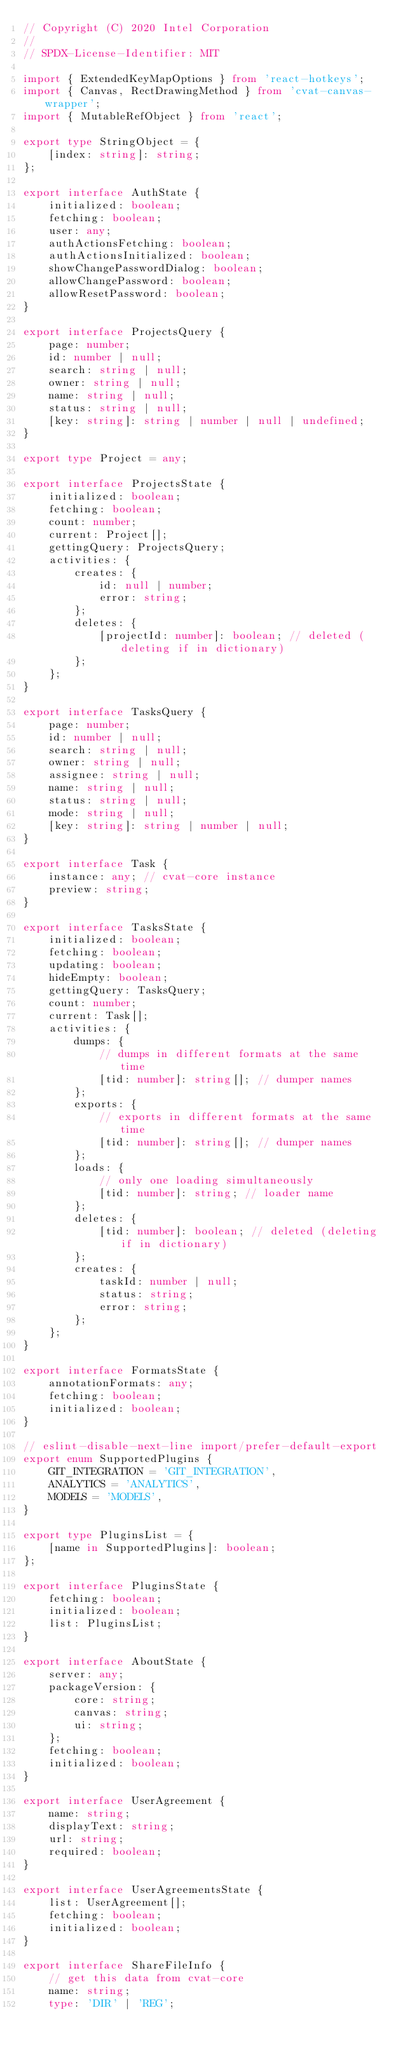<code> <loc_0><loc_0><loc_500><loc_500><_TypeScript_>// Copyright (C) 2020 Intel Corporation
//
// SPDX-License-Identifier: MIT

import { ExtendedKeyMapOptions } from 'react-hotkeys';
import { Canvas, RectDrawingMethod } from 'cvat-canvas-wrapper';
import { MutableRefObject } from 'react';

export type StringObject = {
    [index: string]: string;
};

export interface AuthState {
    initialized: boolean;
    fetching: boolean;
    user: any;
    authActionsFetching: boolean;
    authActionsInitialized: boolean;
    showChangePasswordDialog: boolean;
    allowChangePassword: boolean;
    allowResetPassword: boolean;
}

export interface ProjectsQuery {
    page: number;
    id: number | null;
    search: string | null;
    owner: string | null;
    name: string | null;
    status: string | null;
    [key: string]: string | number | null | undefined;
}

export type Project = any;

export interface ProjectsState {
    initialized: boolean;
    fetching: boolean;
    count: number;
    current: Project[];
    gettingQuery: ProjectsQuery;
    activities: {
        creates: {
            id: null | number;
            error: string;
        };
        deletes: {
            [projectId: number]: boolean; // deleted (deleting if in dictionary)
        };
    };
}

export interface TasksQuery {
    page: number;
    id: number | null;
    search: string | null;
    owner: string | null;
    assignee: string | null;
    name: string | null;
    status: string | null;
    mode: string | null;
    [key: string]: string | number | null;
}

export interface Task {
    instance: any; // cvat-core instance
    preview: string;
}

export interface TasksState {
    initialized: boolean;
    fetching: boolean;
    updating: boolean;
    hideEmpty: boolean;
    gettingQuery: TasksQuery;
    count: number;
    current: Task[];
    activities: {
        dumps: {
            // dumps in different formats at the same time
            [tid: number]: string[]; // dumper names
        };
        exports: {
            // exports in different formats at the same time
            [tid: number]: string[]; // dumper names
        };
        loads: {
            // only one loading simultaneously
            [tid: number]: string; // loader name
        };
        deletes: {
            [tid: number]: boolean; // deleted (deleting if in dictionary)
        };
        creates: {
            taskId: number | null;
            status: string;
            error: string;
        };
    };
}

export interface FormatsState {
    annotationFormats: any;
    fetching: boolean;
    initialized: boolean;
}

// eslint-disable-next-line import/prefer-default-export
export enum SupportedPlugins {
    GIT_INTEGRATION = 'GIT_INTEGRATION',
    ANALYTICS = 'ANALYTICS',
    MODELS = 'MODELS',
}

export type PluginsList = {
    [name in SupportedPlugins]: boolean;
};

export interface PluginsState {
    fetching: boolean;
    initialized: boolean;
    list: PluginsList;
}

export interface AboutState {
    server: any;
    packageVersion: {
        core: string;
        canvas: string;
        ui: string;
    };
    fetching: boolean;
    initialized: boolean;
}

export interface UserAgreement {
    name: string;
    displayText: string;
    url: string;
    required: boolean;
}

export interface UserAgreementsState {
    list: UserAgreement[];
    fetching: boolean;
    initialized: boolean;
}

export interface ShareFileInfo {
    // get this data from cvat-core
    name: string;
    type: 'DIR' | 'REG';</code> 